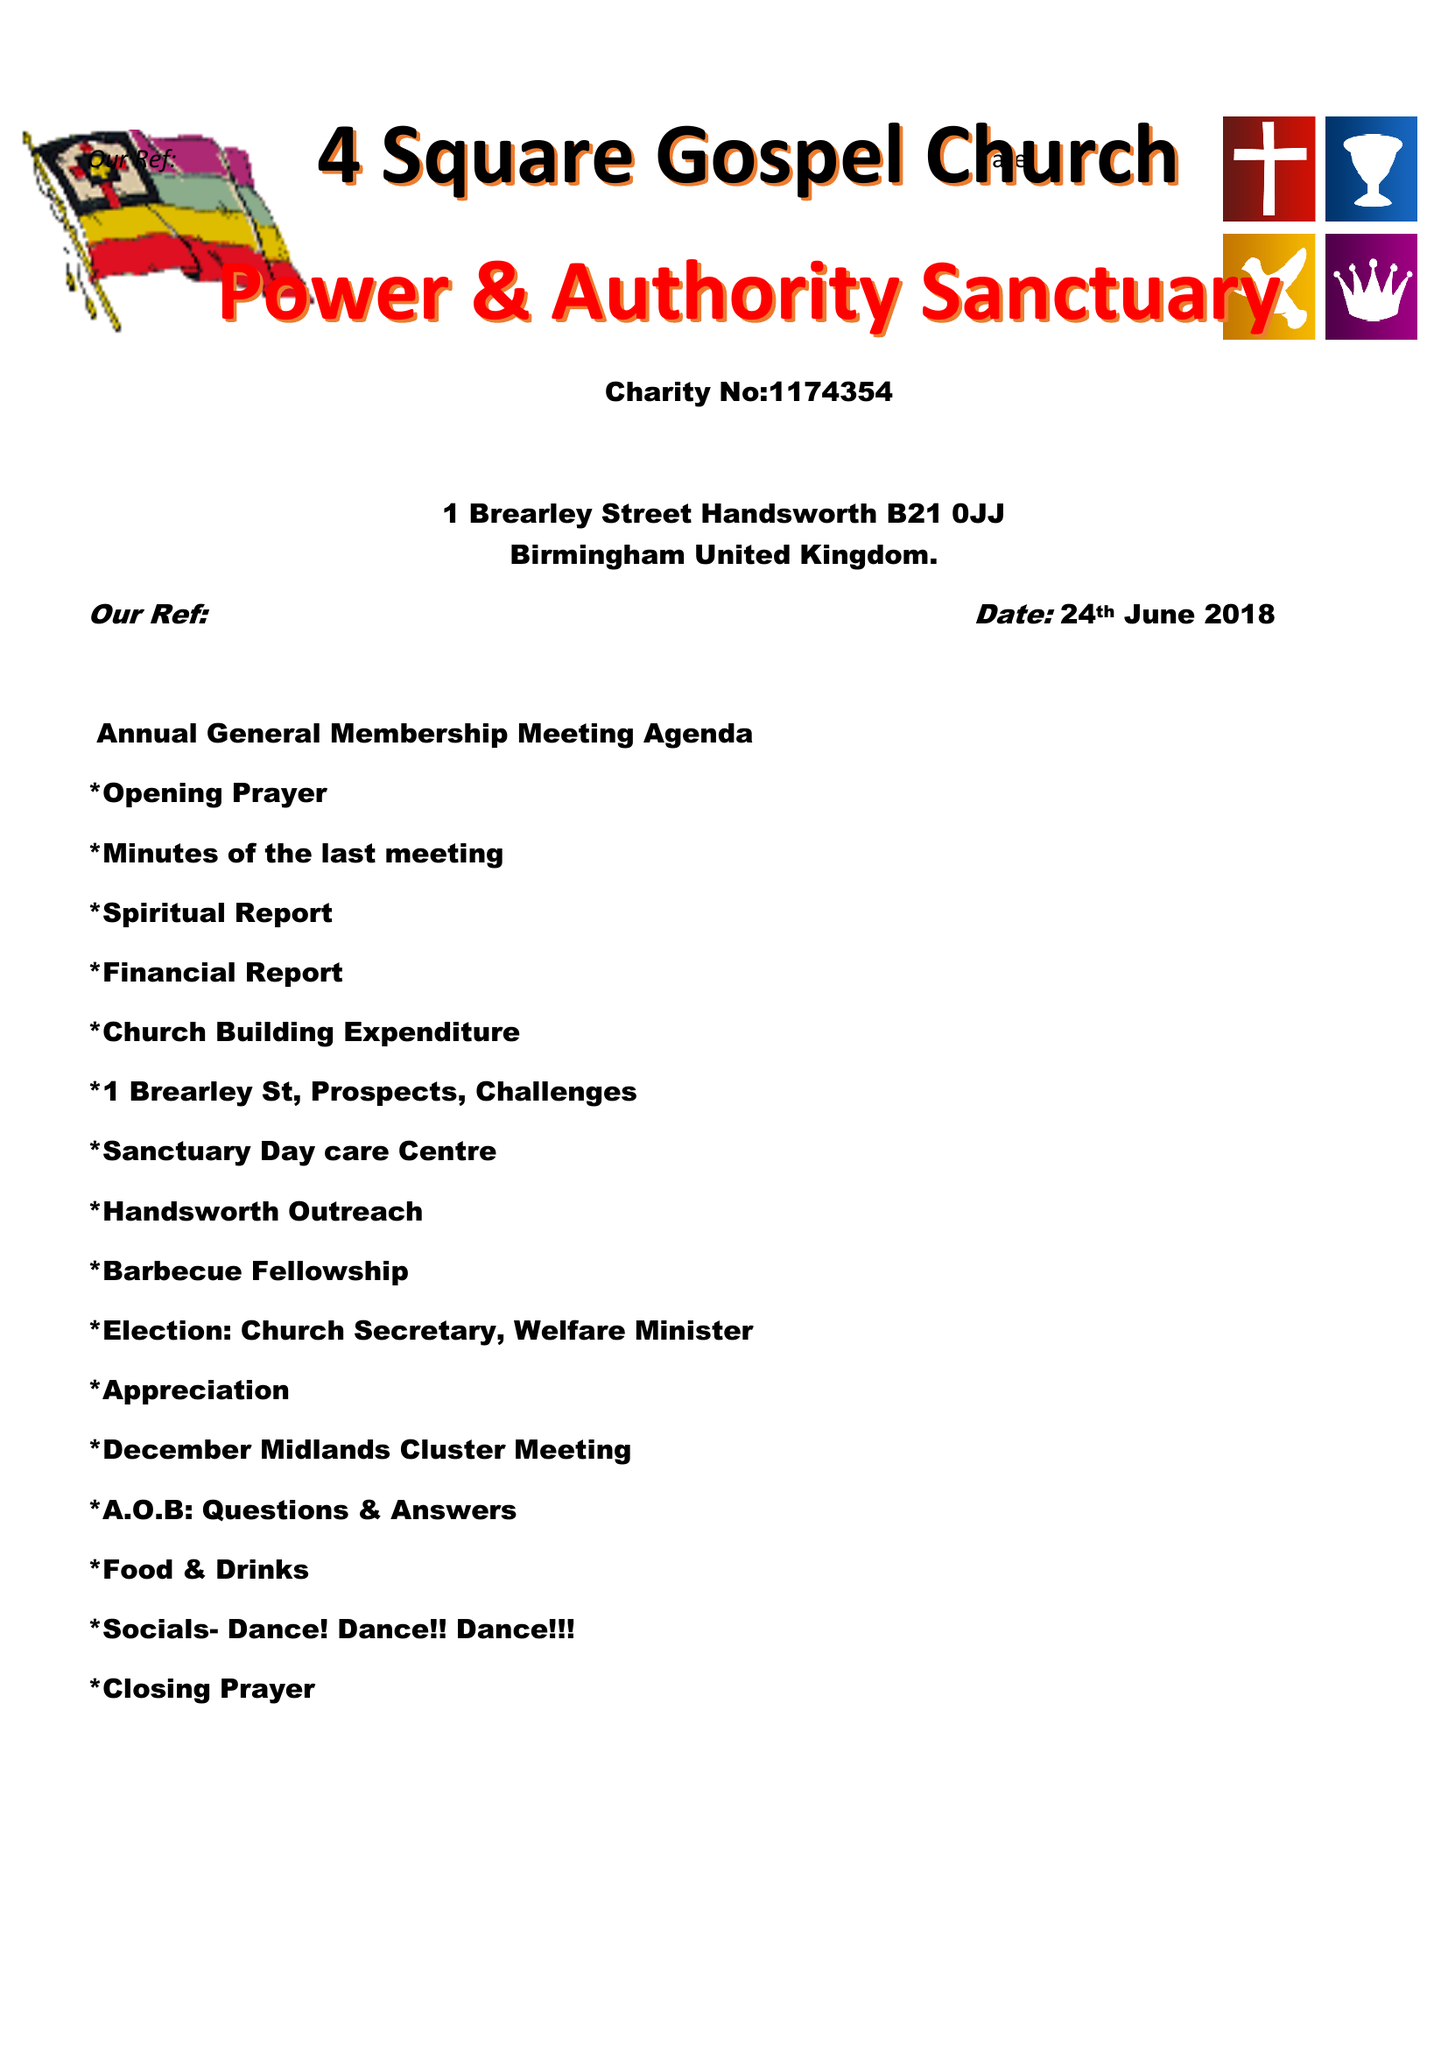What is the value for the charity_number?
Answer the question using a single word or phrase. 1174354 